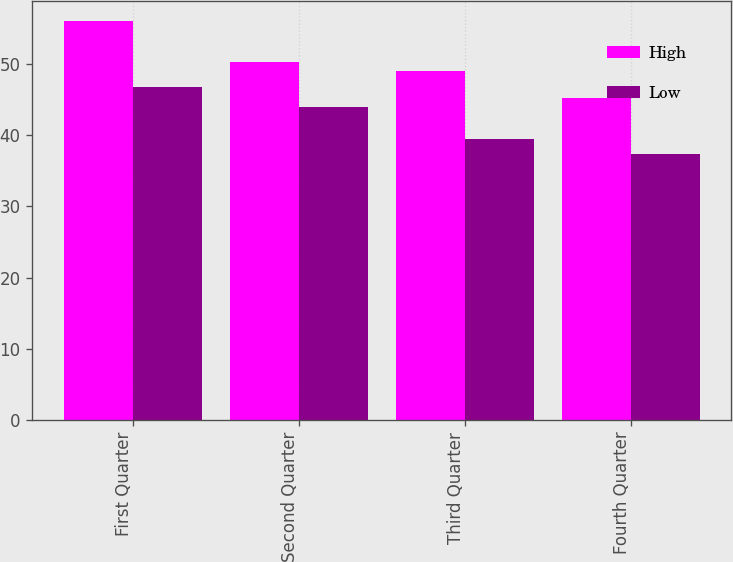Convert chart to OTSL. <chart><loc_0><loc_0><loc_500><loc_500><stacked_bar_chart><ecel><fcel>First Quarter<fcel>Second Quarter<fcel>Third Quarter<fcel>Fourth Quarter<nl><fcel>High<fcel>56<fcel>50.21<fcel>49.04<fcel>45.23<nl><fcel>Low<fcel>46.77<fcel>44.01<fcel>39.45<fcel>37.3<nl></chart> 